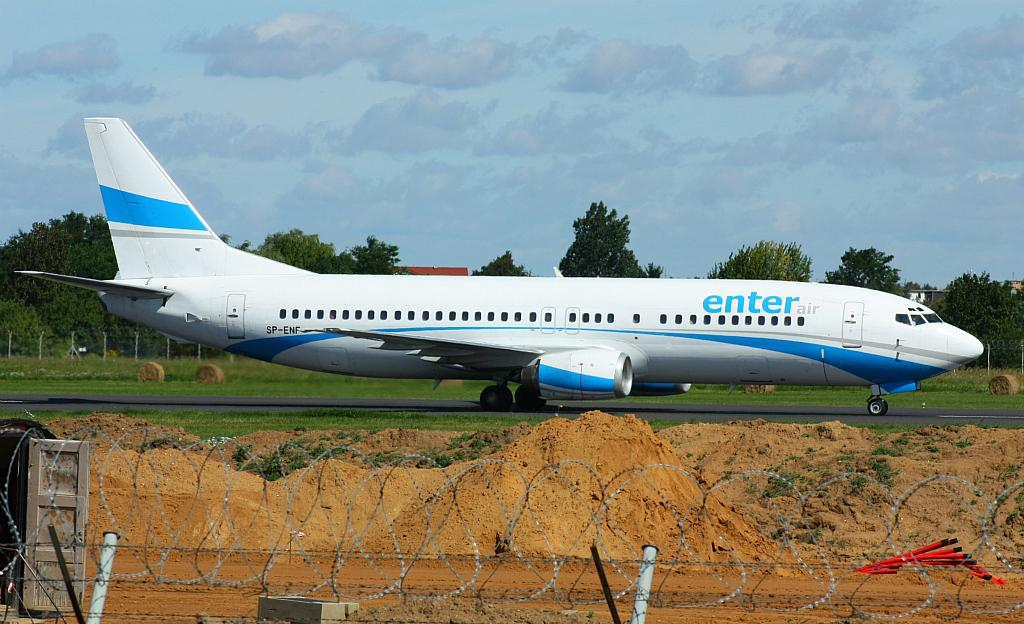Provide a one-sentence caption for the provided image. Blue and white enter air airplane SP-ENF label. 